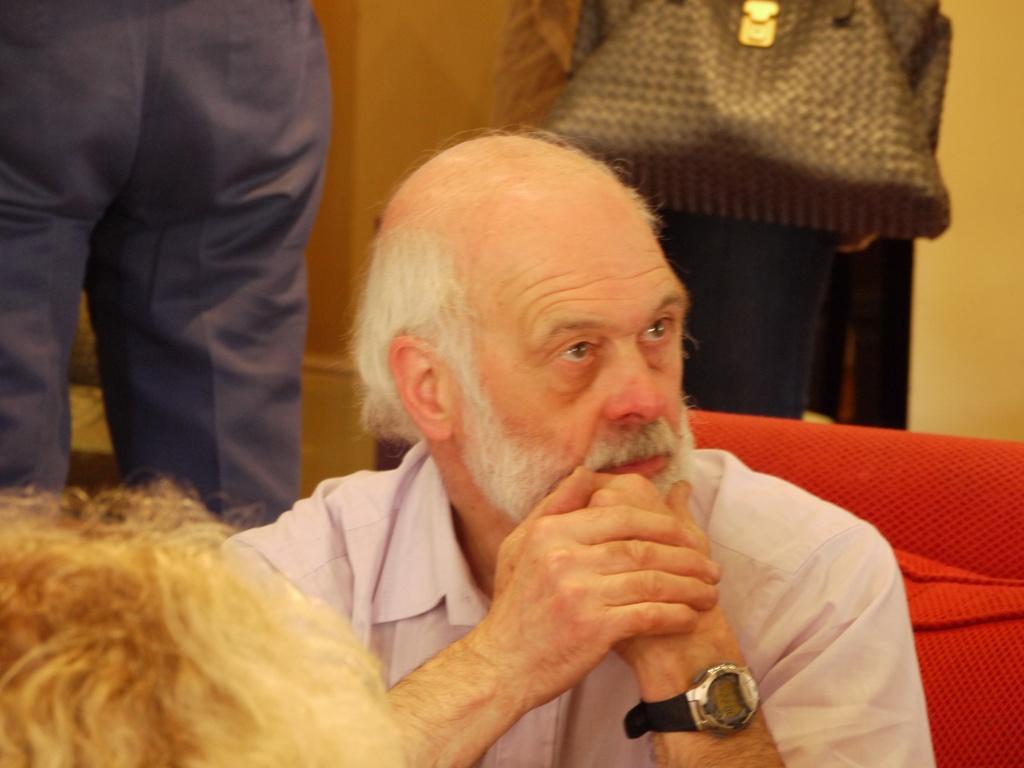Describe this image in one or two sentences. In this image there is an old man sitting on the sofa and in front of him we can see the head of the other person, behind him there are two people standing, one of them is holding a bag. In the background there is a wall. 